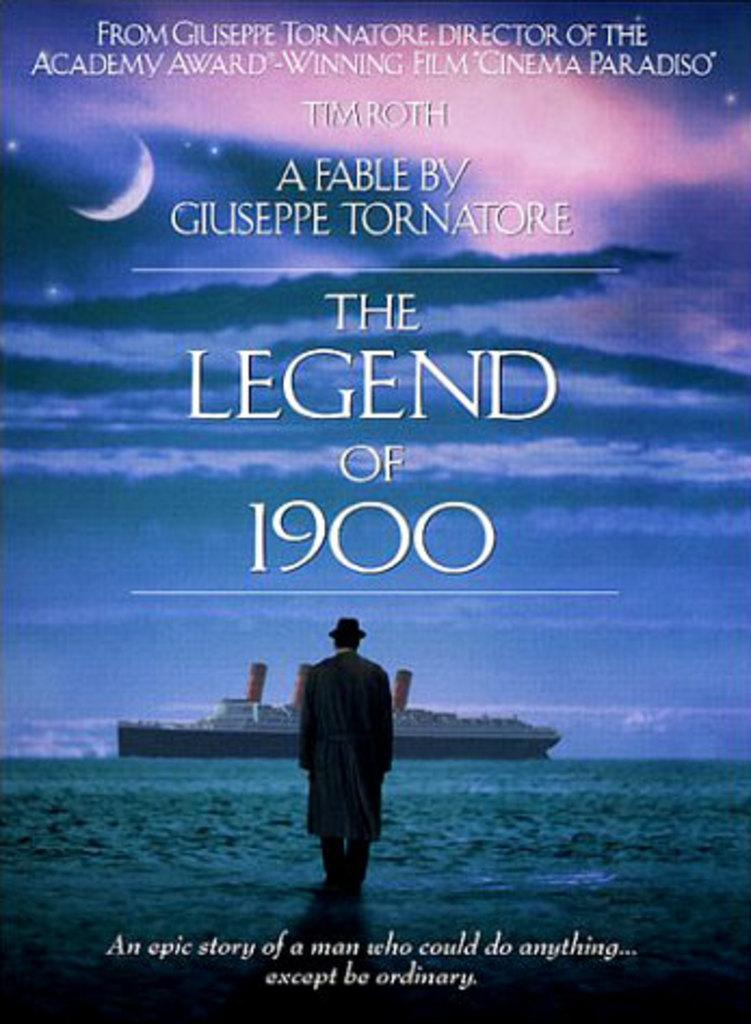Provide a one-sentence caption for the provided image. a movie poster called the legend of 1900. 